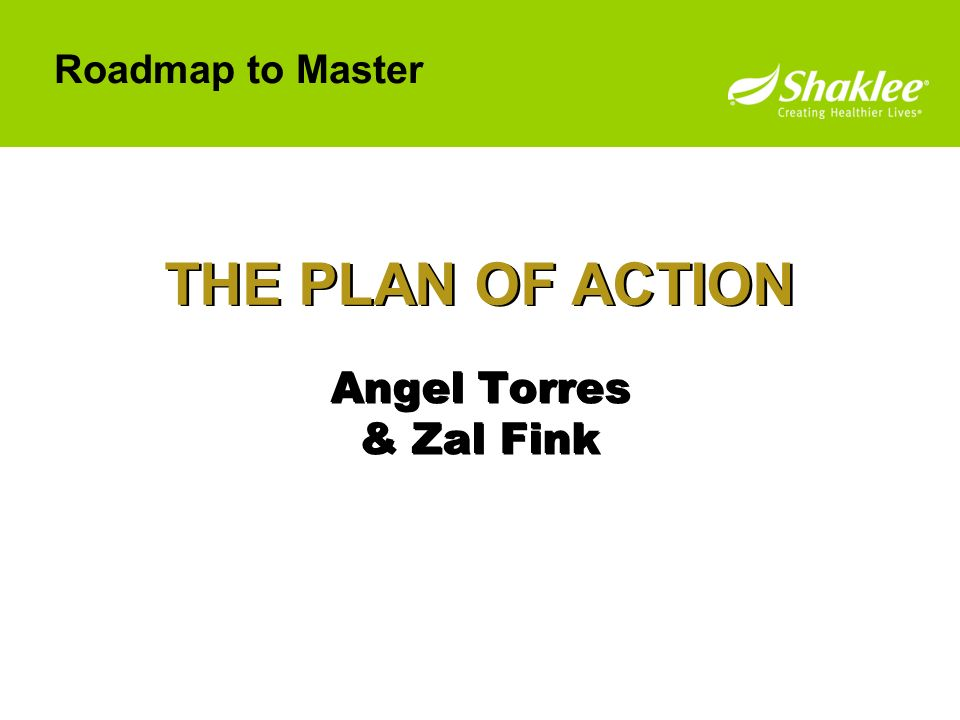Imagine the story behind this slide being used in a superhero team meeting. What would that look like? Imagine a room filled with superheroes, each with unique powers and costumes. The atmosphere is intense as the leader, 'Captain Command,' stands at the front. The slide on the screen, titled 'THE PLAN OF ACTION,' outlines their strategy to thwart an imminent threat. The names 'Angel Torres & Zal Fink' represent their code names, 'Tech Savvy' and 'Strategist Supreme,' who have devised a foolproof plan to neutralize the villain's plot. The superheroes sit around a holographic table, discussing their roles and synchronizing their efforts. The energy is electric as they prepare to deploy their skills in a coordinated attack, ensuring the safety of the city. 